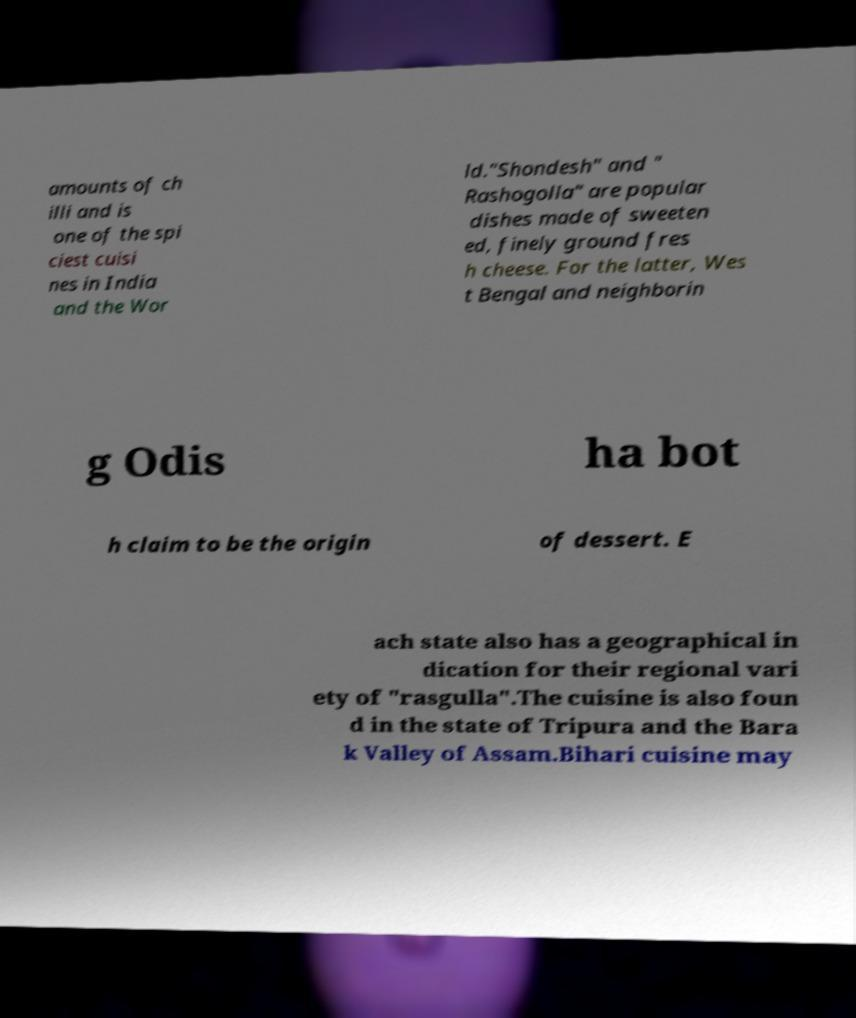Could you assist in decoding the text presented in this image and type it out clearly? amounts of ch illi and is one of the spi ciest cuisi nes in India and the Wor ld."Shondesh" and " Rashogolla" are popular dishes made of sweeten ed, finely ground fres h cheese. For the latter, Wes t Bengal and neighborin g Odis ha bot h claim to be the origin of dessert. E ach state also has a geographical in dication for their regional vari ety of "rasgulla".The cuisine is also foun d in the state of Tripura and the Bara k Valley of Assam.Bihari cuisine may 